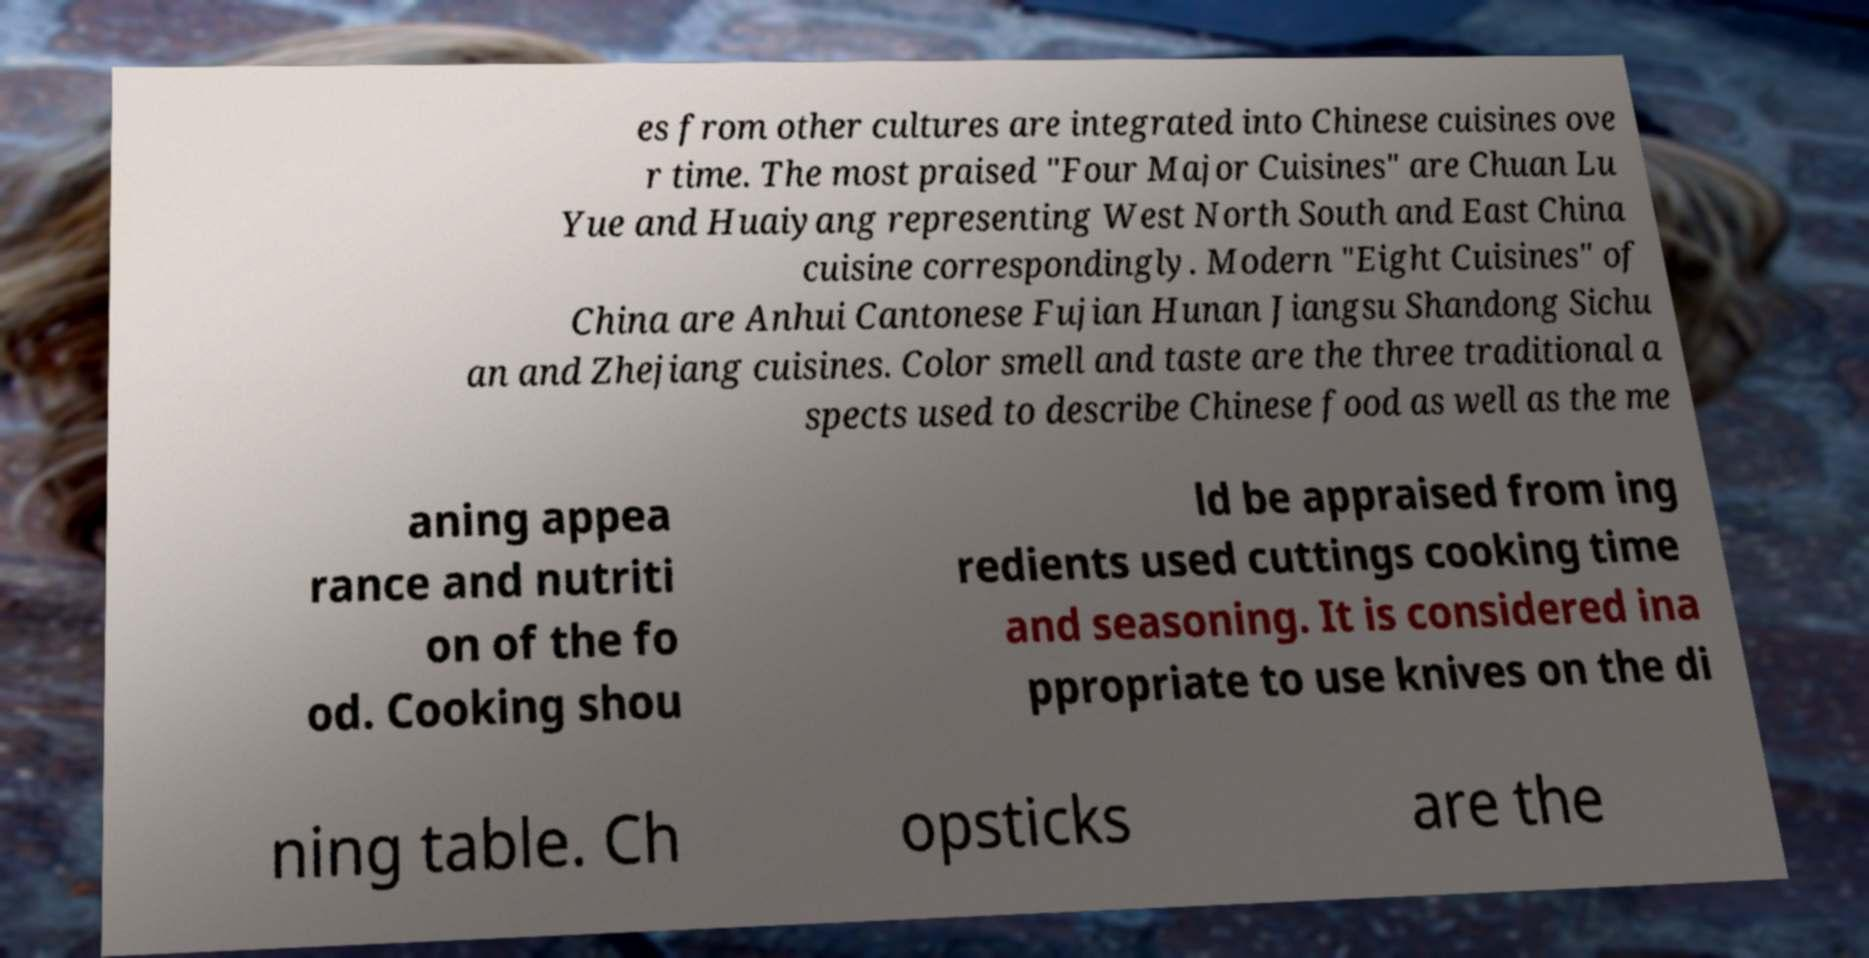Could you assist in decoding the text presented in this image and type it out clearly? es from other cultures are integrated into Chinese cuisines ove r time. The most praised "Four Major Cuisines" are Chuan Lu Yue and Huaiyang representing West North South and East China cuisine correspondingly. Modern "Eight Cuisines" of China are Anhui Cantonese Fujian Hunan Jiangsu Shandong Sichu an and Zhejiang cuisines. Color smell and taste are the three traditional a spects used to describe Chinese food as well as the me aning appea rance and nutriti on of the fo od. Cooking shou ld be appraised from ing redients used cuttings cooking time and seasoning. It is considered ina ppropriate to use knives on the di ning table. Ch opsticks are the 